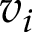Convert formula to latex. <formula><loc_0><loc_0><loc_500><loc_500>v _ { i }</formula> 